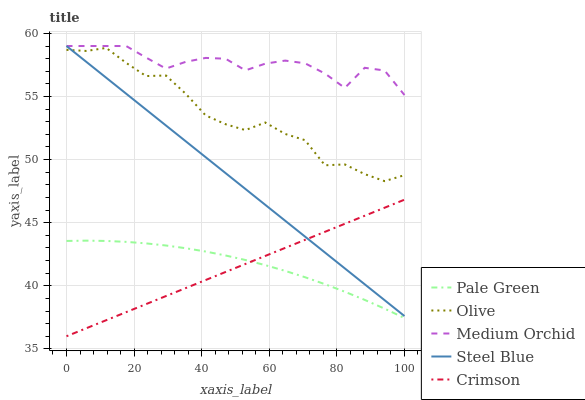Does Crimson have the minimum area under the curve?
Answer yes or no. Yes. Does Medium Orchid have the maximum area under the curve?
Answer yes or no. Yes. Does Medium Orchid have the minimum area under the curve?
Answer yes or no. No. Does Crimson have the maximum area under the curve?
Answer yes or no. No. Is Crimson the smoothest?
Answer yes or no. Yes. Is Olive the roughest?
Answer yes or no. Yes. Is Medium Orchid the smoothest?
Answer yes or no. No. Is Medium Orchid the roughest?
Answer yes or no. No. Does Medium Orchid have the lowest value?
Answer yes or no. No. Does Crimson have the highest value?
Answer yes or no. No. Is Crimson less than Olive?
Answer yes or no. Yes. Is Medium Orchid greater than Pale Green?
Answer yes or no. Yes. Does Crimson intersect Olive?
Answer yes or no. No. 